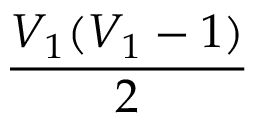Convert formula to latex. <formula><loc_0><loc_0><loc_500><loc_500>\frac { V _ { 1 } ( V _ { 1 } - 1 ) } { 2 }</formula> 